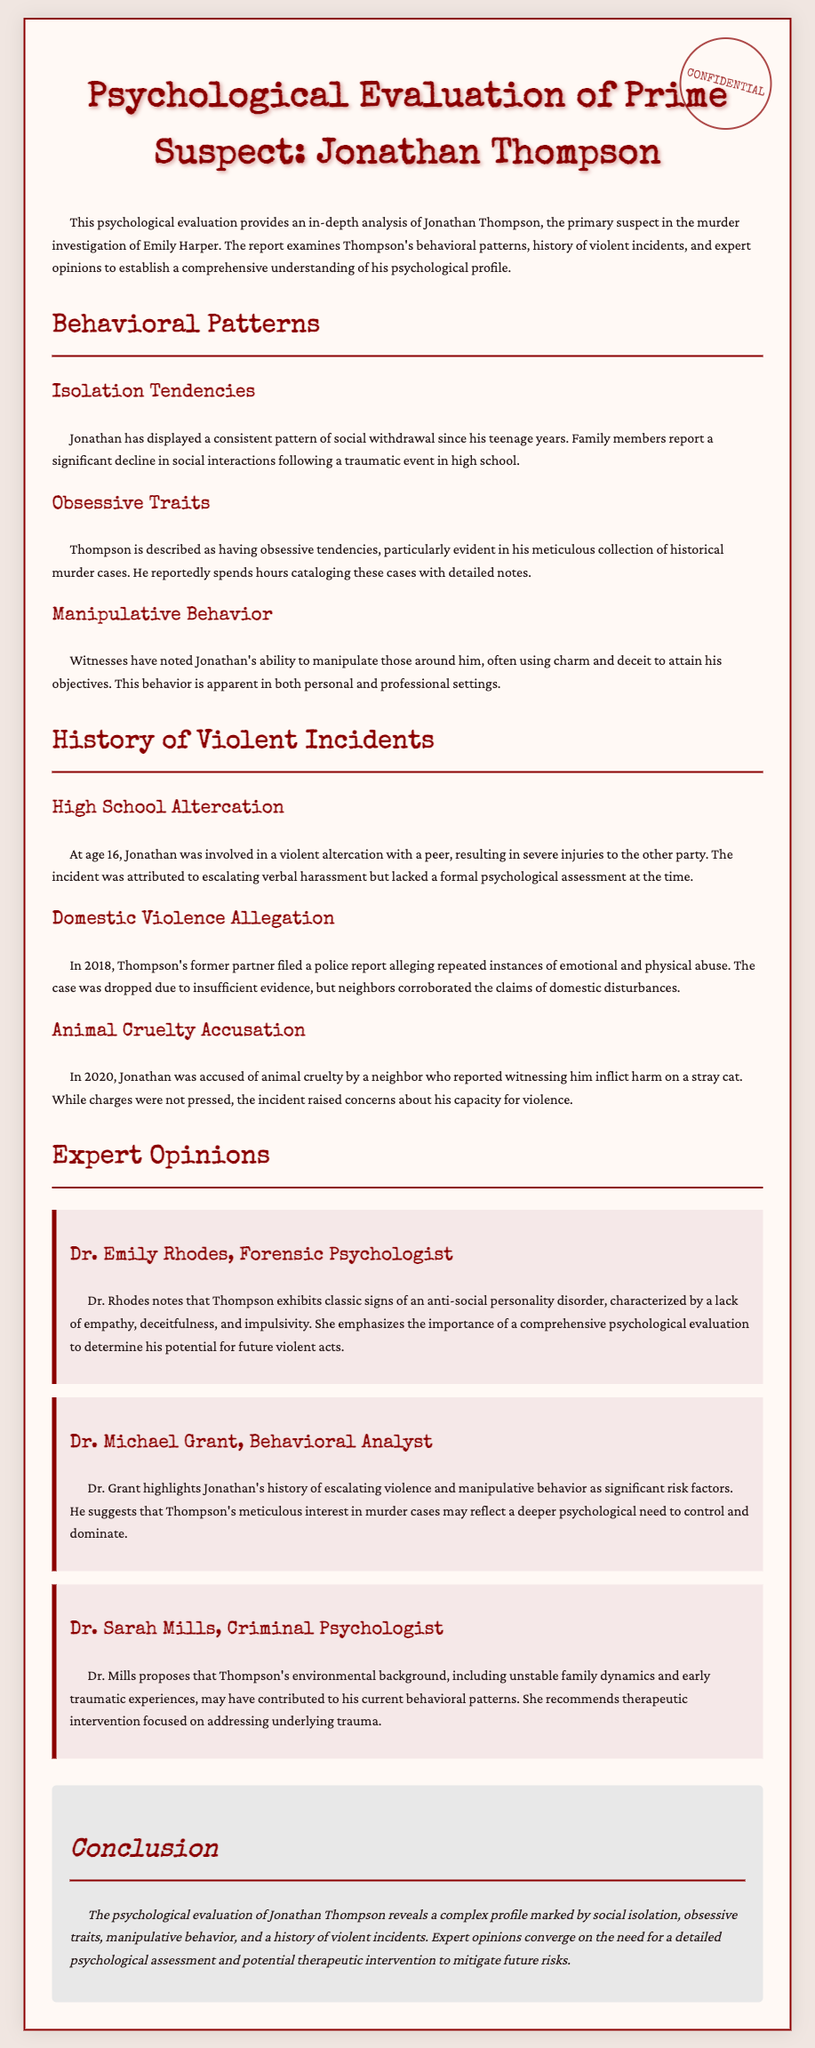What is the name of the prime suspect? The prime suspect in the evaluation is identified in the title of the document as Jonathan Thompson.
Answer: Jonathan Thompson In what year was the domestic violence allegation made? The document states that the domestic violence allegation was filed in 2018.
Answer: 2018 Who provided an opinion stating that Thompson exhibits classic signs of an anti-social personality disorder? The expert opinion mentioning anti-social personality disorder was given by Dr. Emily Rhodes.
Answer: Dr. Emily Rhodes What traumatic event is referenced regarding Jonathan's social withdrawal? The document mentions that the social withdrawal followed a traumatic event in high school.
Answer: Traumatic event in high school Which expert suggested that therapeutic intervention could address underlying trauma? Dr. Sarah Mills is the expert who proposed the need for therapeutic intervention to address trauma.
Answer: Dr. Sarah Mills What behavior is characterized by Jonathan's meticulous cataloging of murder cases? This behavior is described as obsessive traits in the evaluation.
Answer: Obsessive traits What type of behavior is noted as manipulative by witnesses? Witnesses have observed Jonathan's ability to manipulate others using charm and deceit.
Answer: Manipulative behavior What was the nature of the incident involving the stray cat? The document details Jonathan being accused of animal cruelty concerning the stray cat.
Answer: Animal cruelty What is a significant risk factor highlighted by Dr. Grant? Dr. Grant identifies Jonathan's history of escalating violence as a significant risk factor.
Answer: Escalating violence 